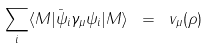<formula> <loc_0><loc_0><loc_500><loc_500>\sum _ { i } \langle M | \bar { \psi } _ { i } \gamma _ { \mu } \psi _ { i } | M \rangle \ = \ v _ { \mu } ( \rho )</formula> 